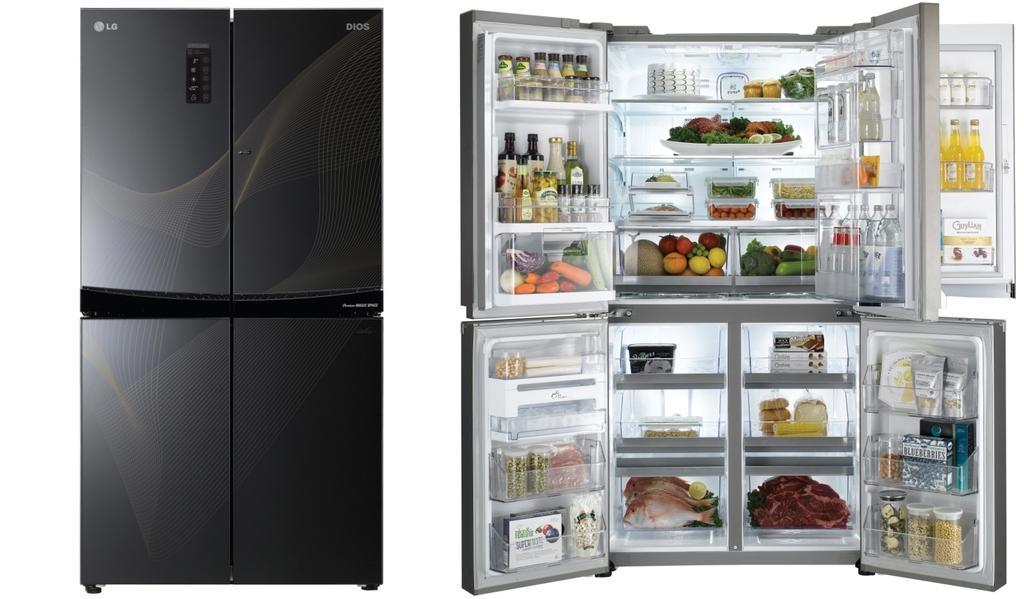In one or two sentences, can you explain what this image depicts? This is an edited image. Here I can see two refrigerators. The doors are opened to the refrigerator which is on the right side. Here fruits, vegetables, meat, bottles, boxes, some food items and many objects are placed inside the refrigerator. The background is in white color. 